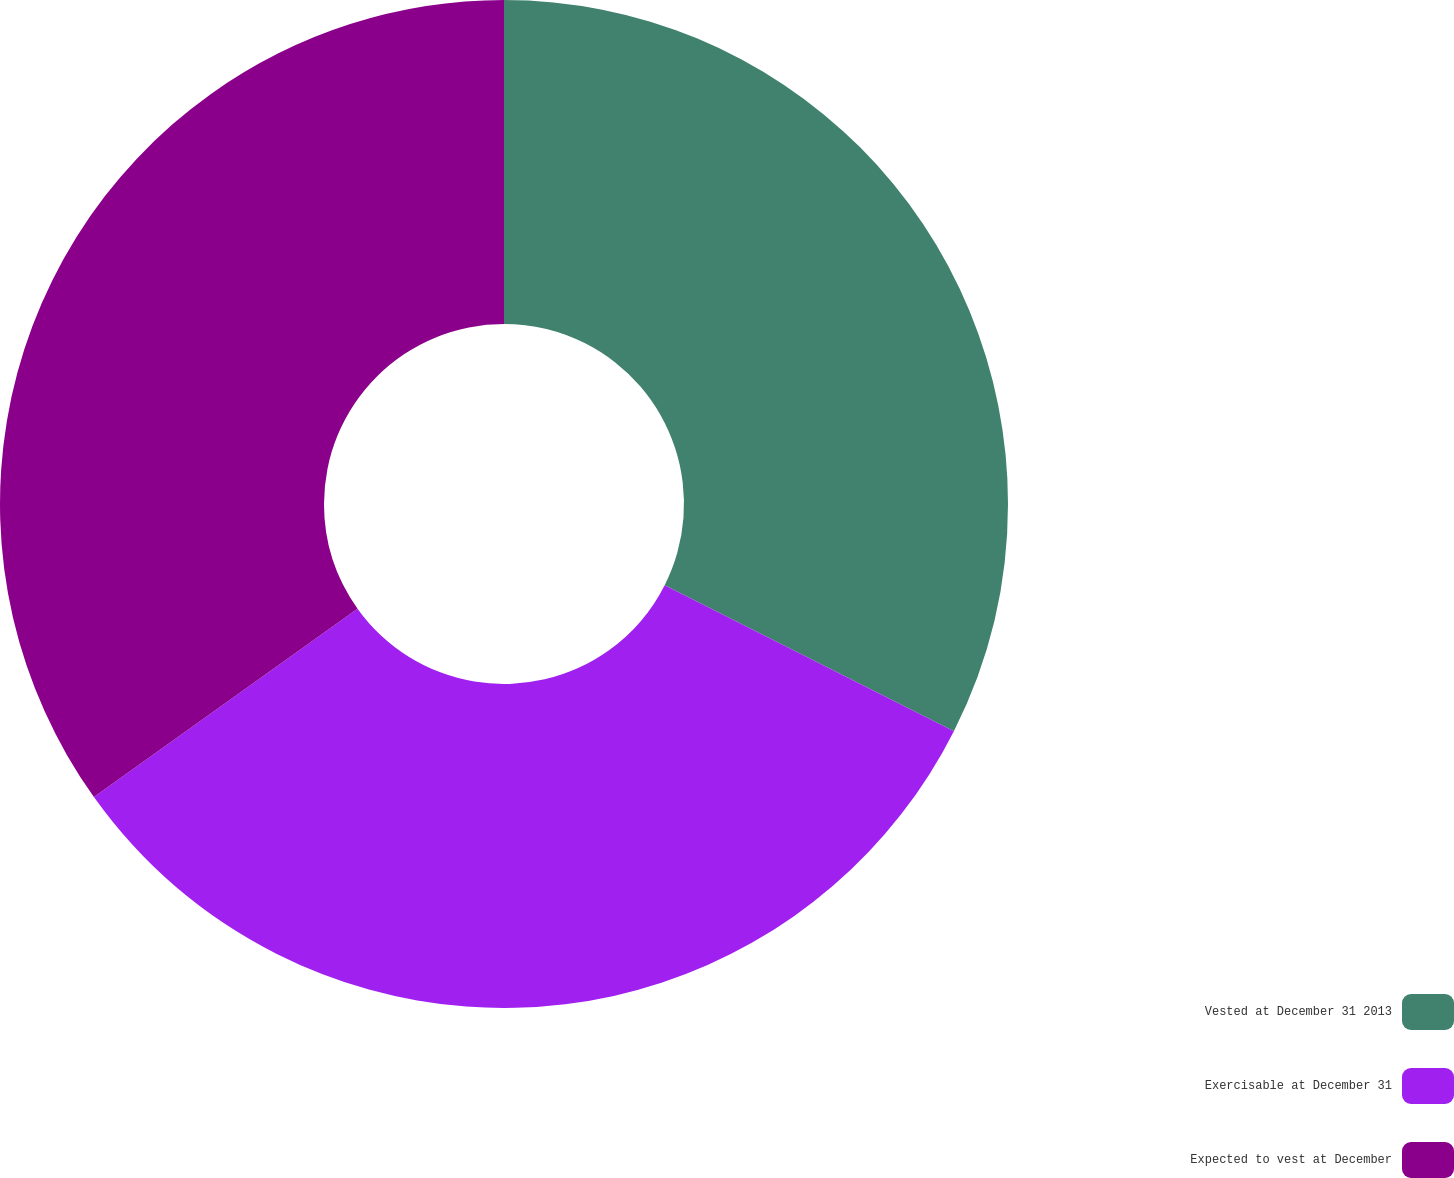Convert chart to OTSL. <chart><loc_0><loc_0><loc_500><loc_500><pie_chart><fcel>Vested at December 31 2013<fcel>Exercisable at December 31<fcel>Expected to vest at December<nl><fcel>32.44%<fcel>32.68%<fcel>34.87%<nl></chart> 